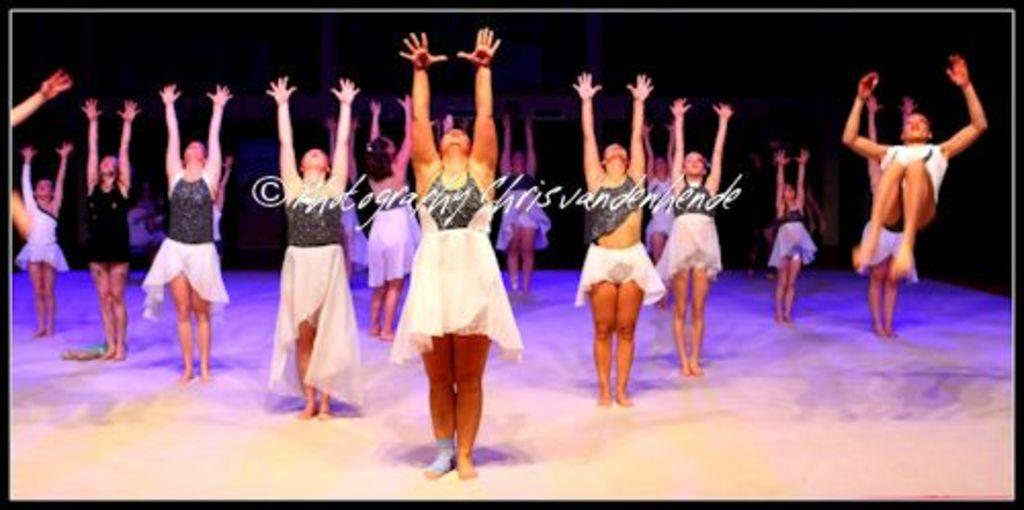What are the people in the image doing with their hands? The people in the image are standing with raised hands. What can be seen in the middle of the image? There is a watermark in the middle of the image. How would you describe the background of the image? The background of the image is dark. What type of pan is being used to measure silver in the image? There is no pan or silver present in the image; it only features people with raised hands and a watermark. 